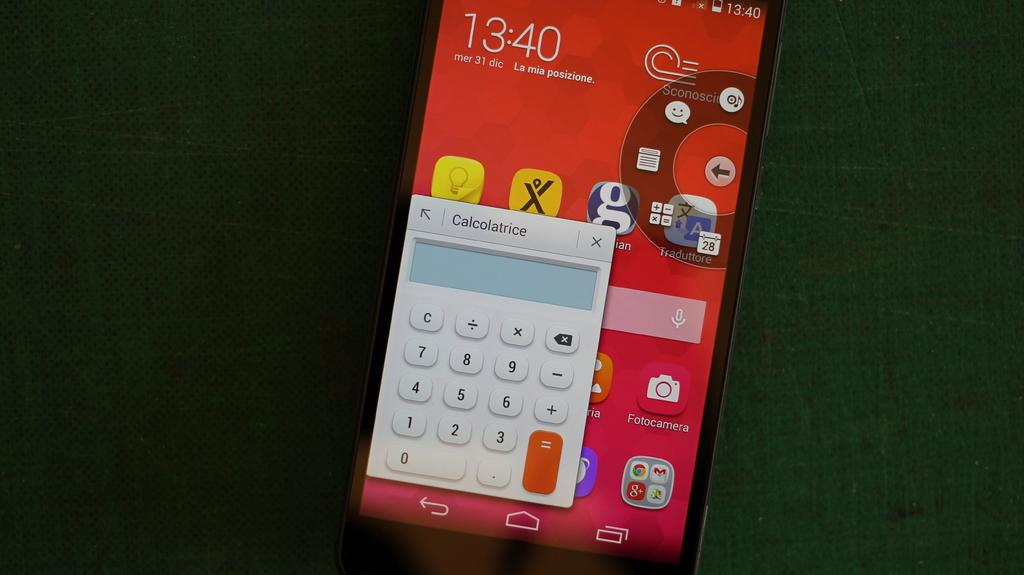<image>
Share a concise interpretation of the image provided. The calculator is the only app opened on the phone. 